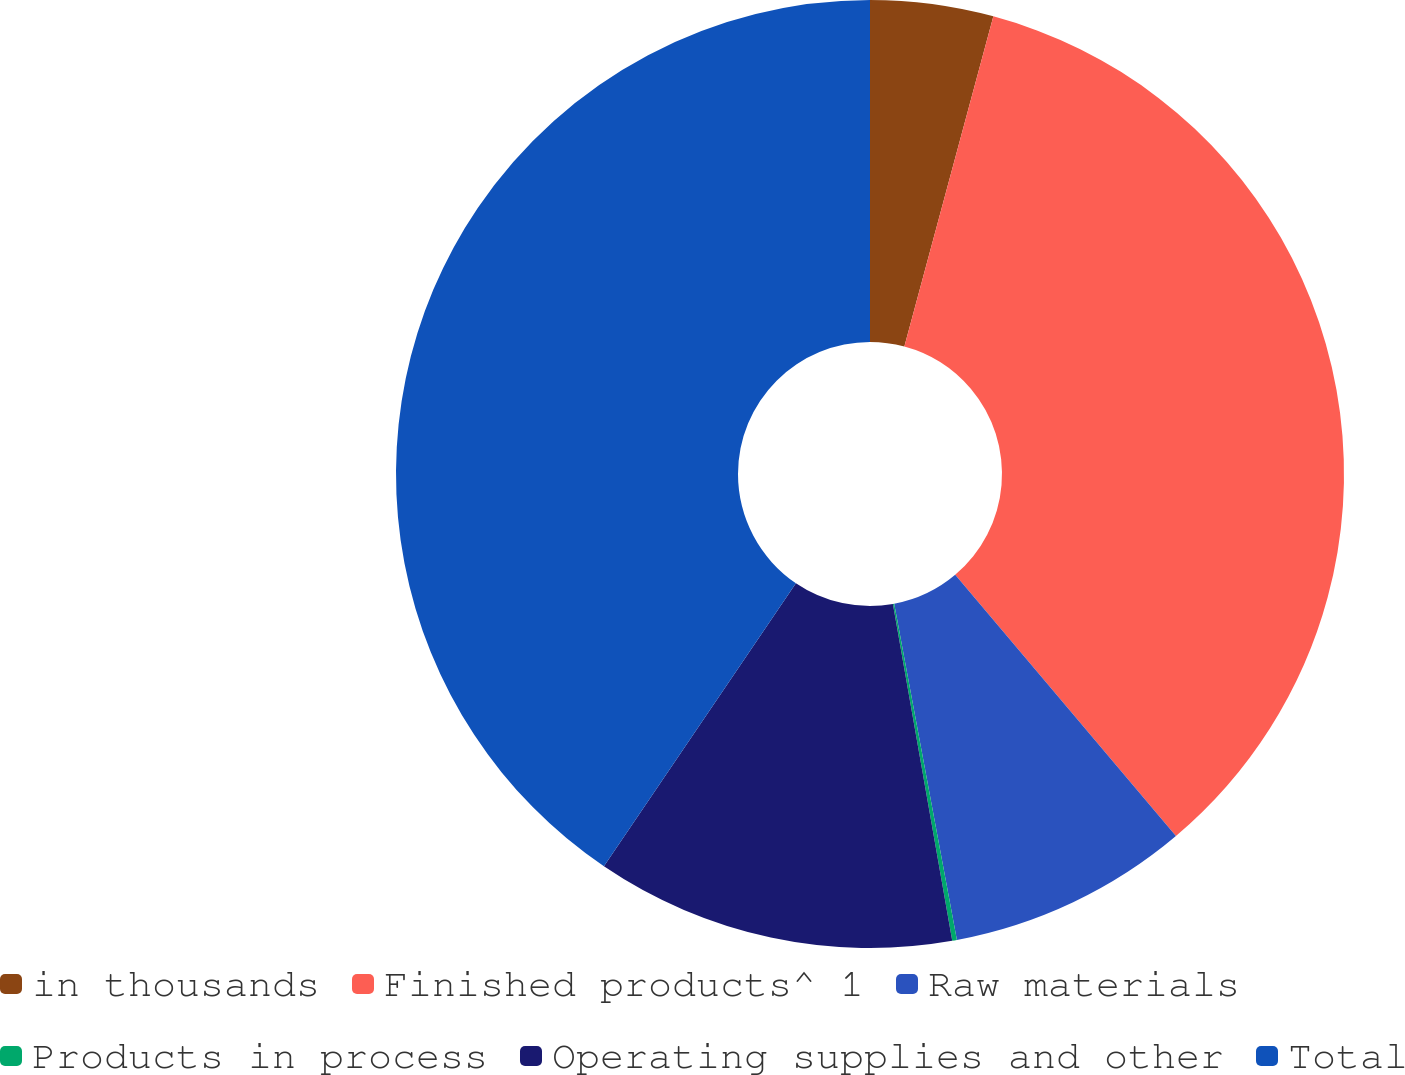Convert chart. <chart><loc_0><loc_0><loc_500><loc_500><pie_chart><fcel>in thousands<fcel>Finished products^ 1<fcel>Raw materials<fcel>Products in process<fcel>Operating supplies and other<fcel>Total<nl><fcel>4.19%<fcel>34.64%<fcel>8.23%<fcel>0.16%<fcel>12.26%<fcel>40.51%<nl></chart> 